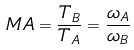Convert formula to latex. <formula><loc_0><loc_0><loc_500><loc_500>M A = \frac { T _ { B } } { T _ { A } } = \frac { \omega _ { A } } { \omega _ { B } }</formula> 